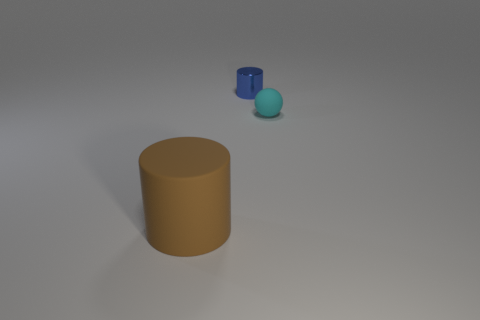Add 3 tiny cylinders. How many objects exist? 6 Subtract all cylinders. How many objects are left? 1 Add 2 rubber cylinders. How many rubber cylinders exist? 3 Subtract 1 cyan spheres. How many objects are left? 2 Subtract all brown shiny cylinders. Subtract all cylinders. How many objects are left? 1 Add 3 tiny balls. How many tiny balls are left? 4 